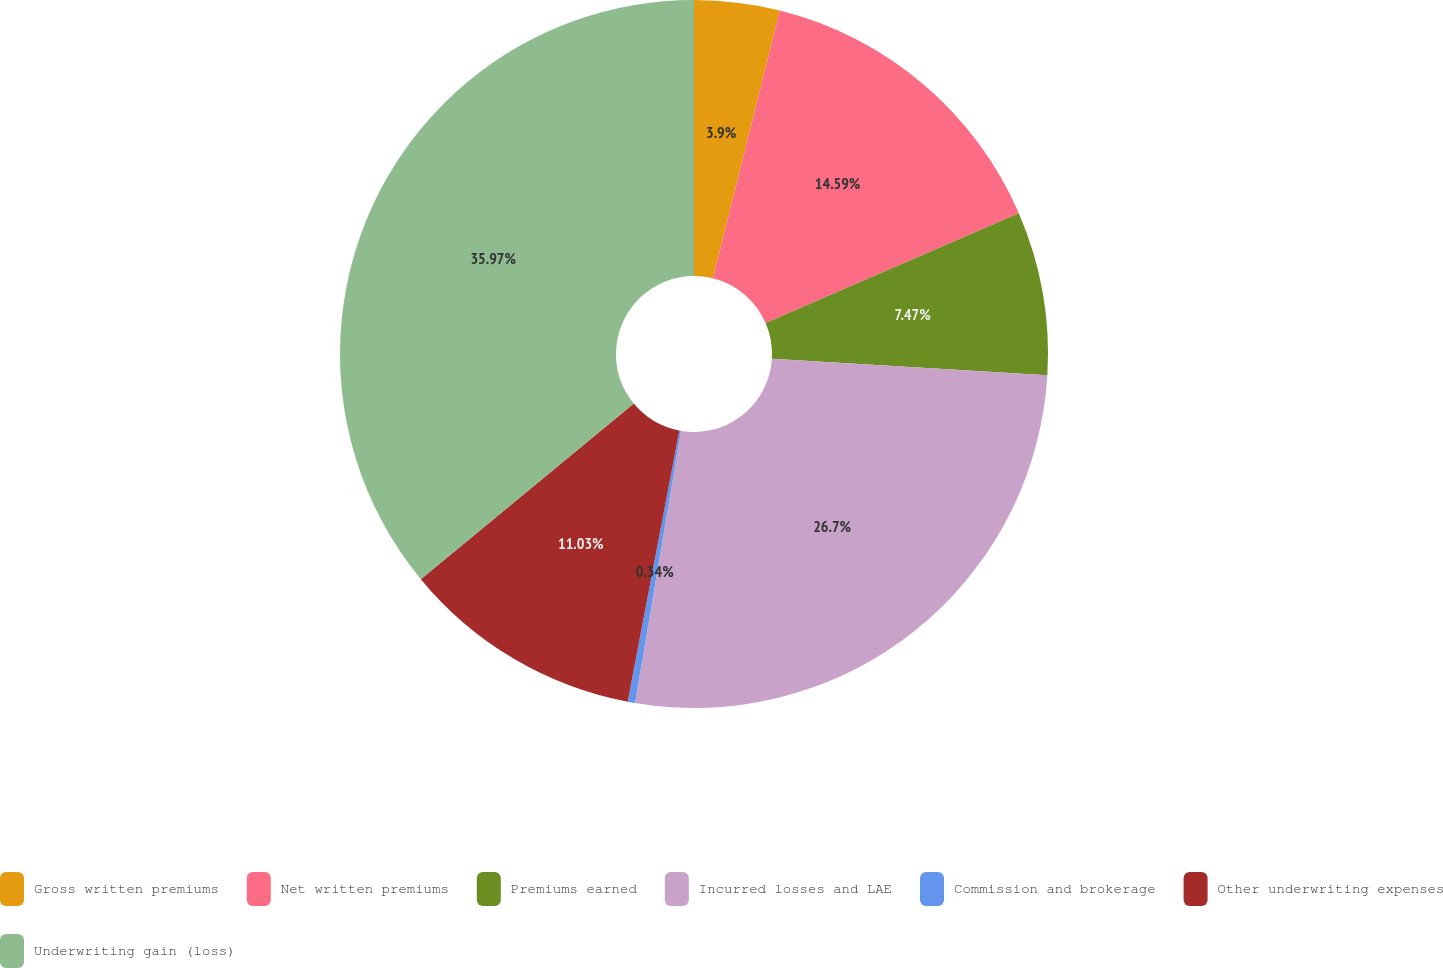Convert chart. <chart><loc_0><loc_0><loc_500><loc_500><pie_chart><fcel>Gross written premiums<fcel>Net written premiums<fcel>Premiums earned<fcel>Incurred losses and LAE<fcel>Commission and brokerage<fcel>Other underwriting expenses<fcel>Underwriting gain (loss)<nl><fcel>3.9%<fcel>14.59%<fcel>7.47%<fcel>26.7%<fcel>0.34%<fcel>11.03%<fcel>35.97%<nl></chart> 